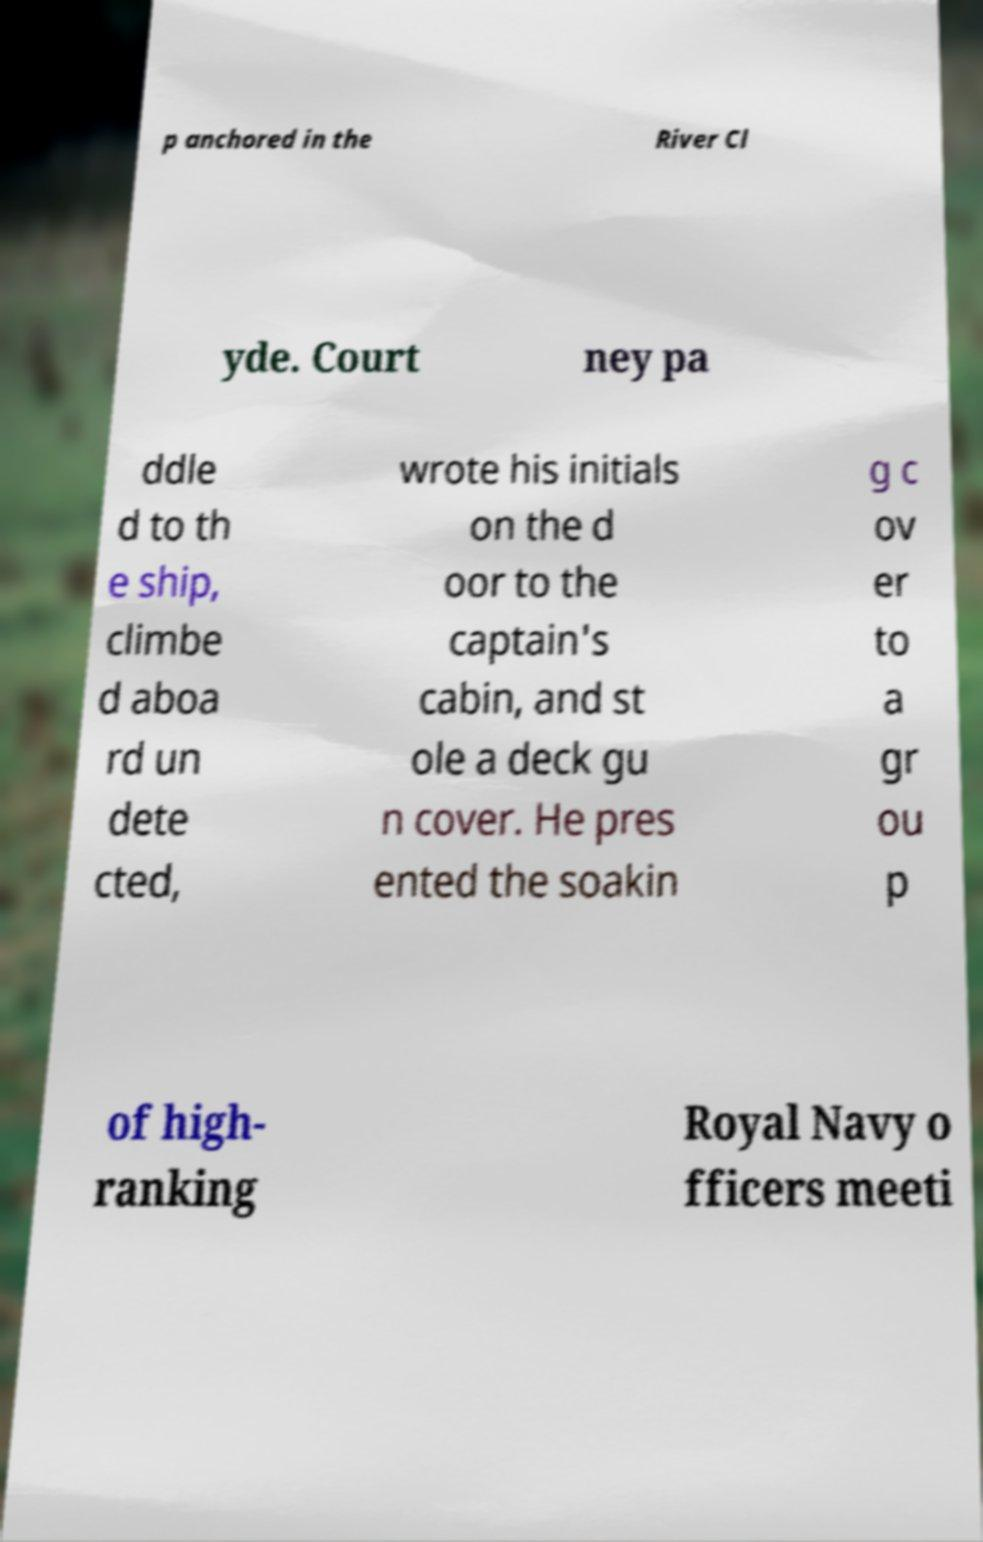Could you extract and type out the text from this image? p anchored in the River Cl yde. Court ney pa ddle d to th e ship, climbe d aboa rd un dete cted, wrote his initials on the d oor to the captain's cabin, and st ole a deck gu n cover. He pres ented the soakin g c ov er to a gr ou p of high- ranking Royal Navy o fficers meeti 